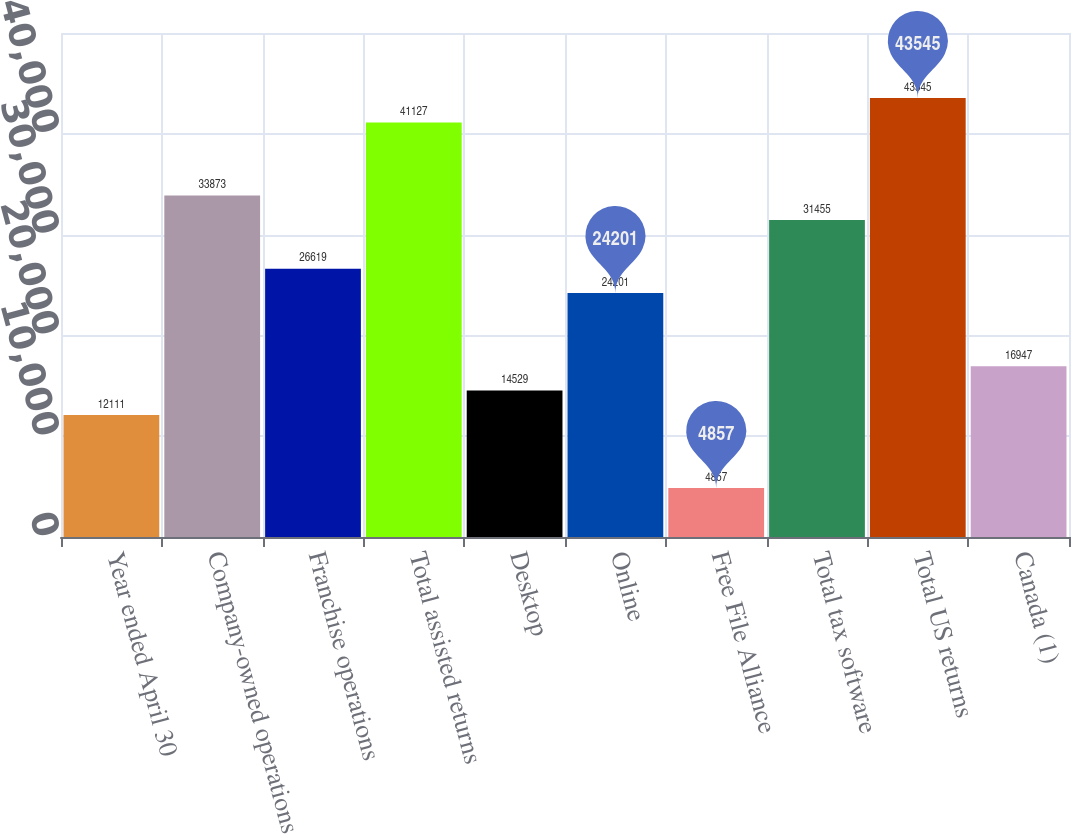Convert chart to OTSL. <chart><loc_0><loc_0><loc_500><loc_500><bar_chart><fcel>Year ended April 30<fcel>Company-owned operations<fcel>Franchise operations<fcel>Total assisted returns<fcel>Desktop<fcel>Online<fcel>Free File Alliance<fcel>Total tax software<fcel>Total US returns<fcel>Canada (1)<nl><fcel>12111<fcel>33873<fcel>26619<fcel>41127<fcel>14529<fcel>24201<fcel>4857<fcel>31455<fcel>43545<fcel>16947<nl></chart> 